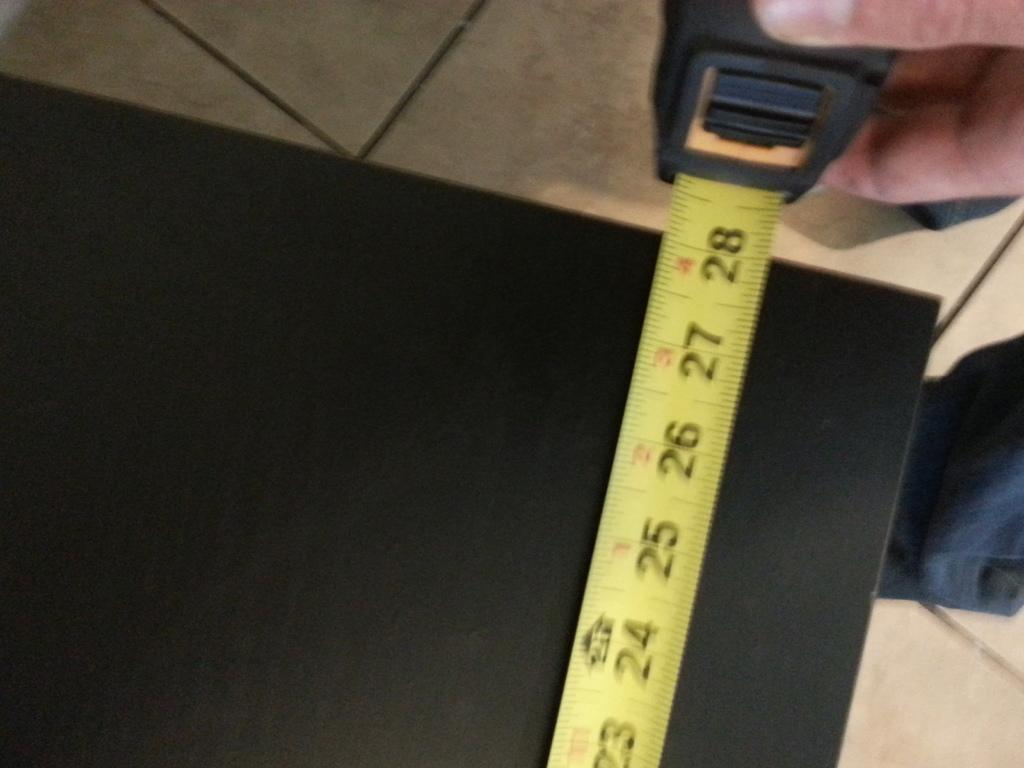<image>
Share a concise interpretation of the image provided. A person measuring a black table which shows 28 inches. 